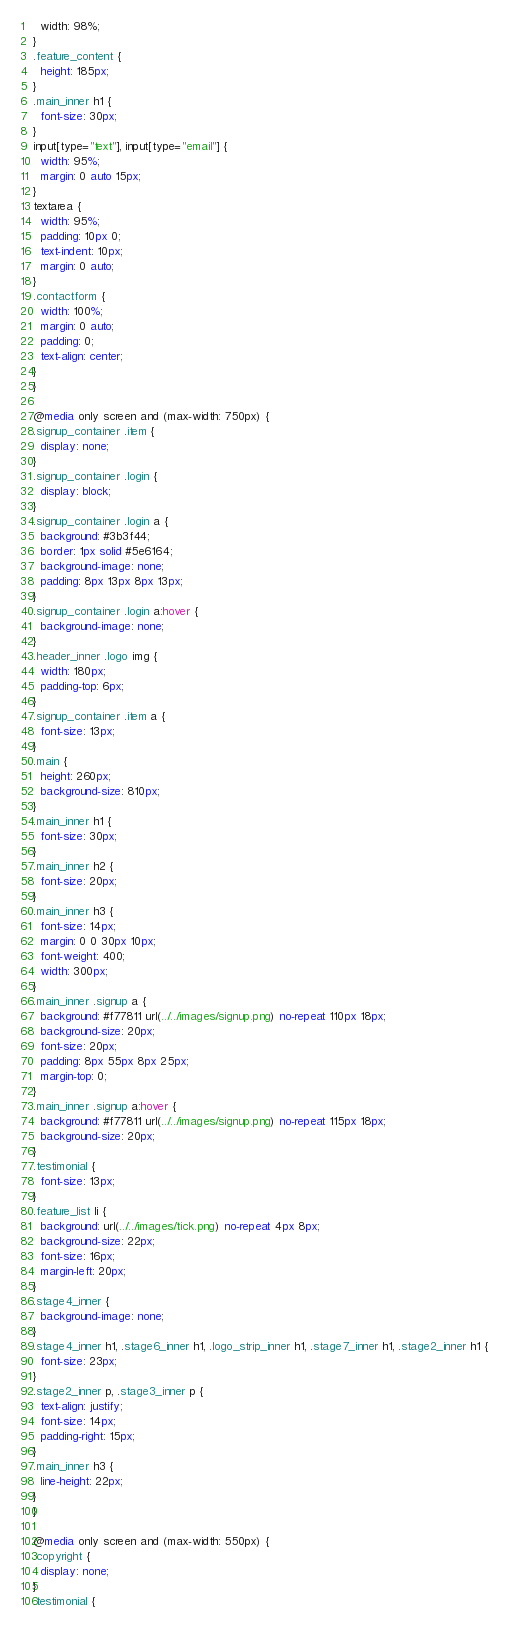<code> <loc_0><loc_0><loc_500><loc_500><_CSS_>  width: 98%;
}
.feature_content {
  height: 185px;
}
.main_inner h1 {
  font-size: 30px;
}
input[type="text"], input[type="email"] {
  width: 95%;
  margin: 0 auto 15px;
}
textarea {
  width: 95%;
  padding: 10px 0;
  text-indent: 10px;
  margin: 0 auto;
}
.contactform {
  width: 100%;
  margin: 0 auto;
  padding: 0;
  text-align: center;
}
}

@media only screen and (max-width: 750px) {
.signup_container .item {
  display: none;
}
.signup_container .login {
  display: block;
}
.signup_container .login a {
  background: #3b3f44;
  border: 1px solid #5e6164;
  background-image: none;
  padding: 8px 13px 8px 13px;
}
.signup_container .login a:hover {
  background-image: none;
}
.header_inner .logo img {
  width: 180px;
  padding-top: 6px;
}
.signup_container .item a {
  font-size: 13px;
}
.main {
  height: 260px;
  background-size: 810px;
}
.main_inner h1 {
  font-size: 30px;
}
.main_inner h2 {
  font-size: 20px;
}
.main_inner h3 {
  font-size: 14px;
  margin: 0 0 30px 10px;
  font-weight: 400;
  width: 300px;
}
.main_inner .signup a {
  background: #f77811 url(../../images/signup.png) no-repeat 110px 18px;
  background-size: 20px;
  font-size: 20px;
  padding: 8px 55px 8px 25px;
  margin-top: 0;
}
.main_inner .signup a:hover {
  background: #f77811 url(../../images/signup.png) no-repeat 115px 18px;
  background-size: 20px;
}
.testimonial {
  font-size: 13px;
}
.feature_list li {
  background: url(../../images/tick.png) no-repeat 4px 8px;
  background-size: 22px;
  font-size: 16px;
  margin-left: 20px;
}
.stage4_inner {
  background-image: none;
}
.stage4_inner h1, .stage6_inner h1, .logo_strip_inner h1, .stage7_inner h1, .stage2_inner h1 {
  font-size: 23px;
}
.stage2_inner p, .stage3_inner p {
  text-align: justify;
  font-size: 14px;
  padding-right: 15px;
}
.main_inner h3 {
  line-height: 22px;
}
}

@media only screen and (max-width: 550px) {
.copyright {
  display: none;
}
.testimonial {</code> 